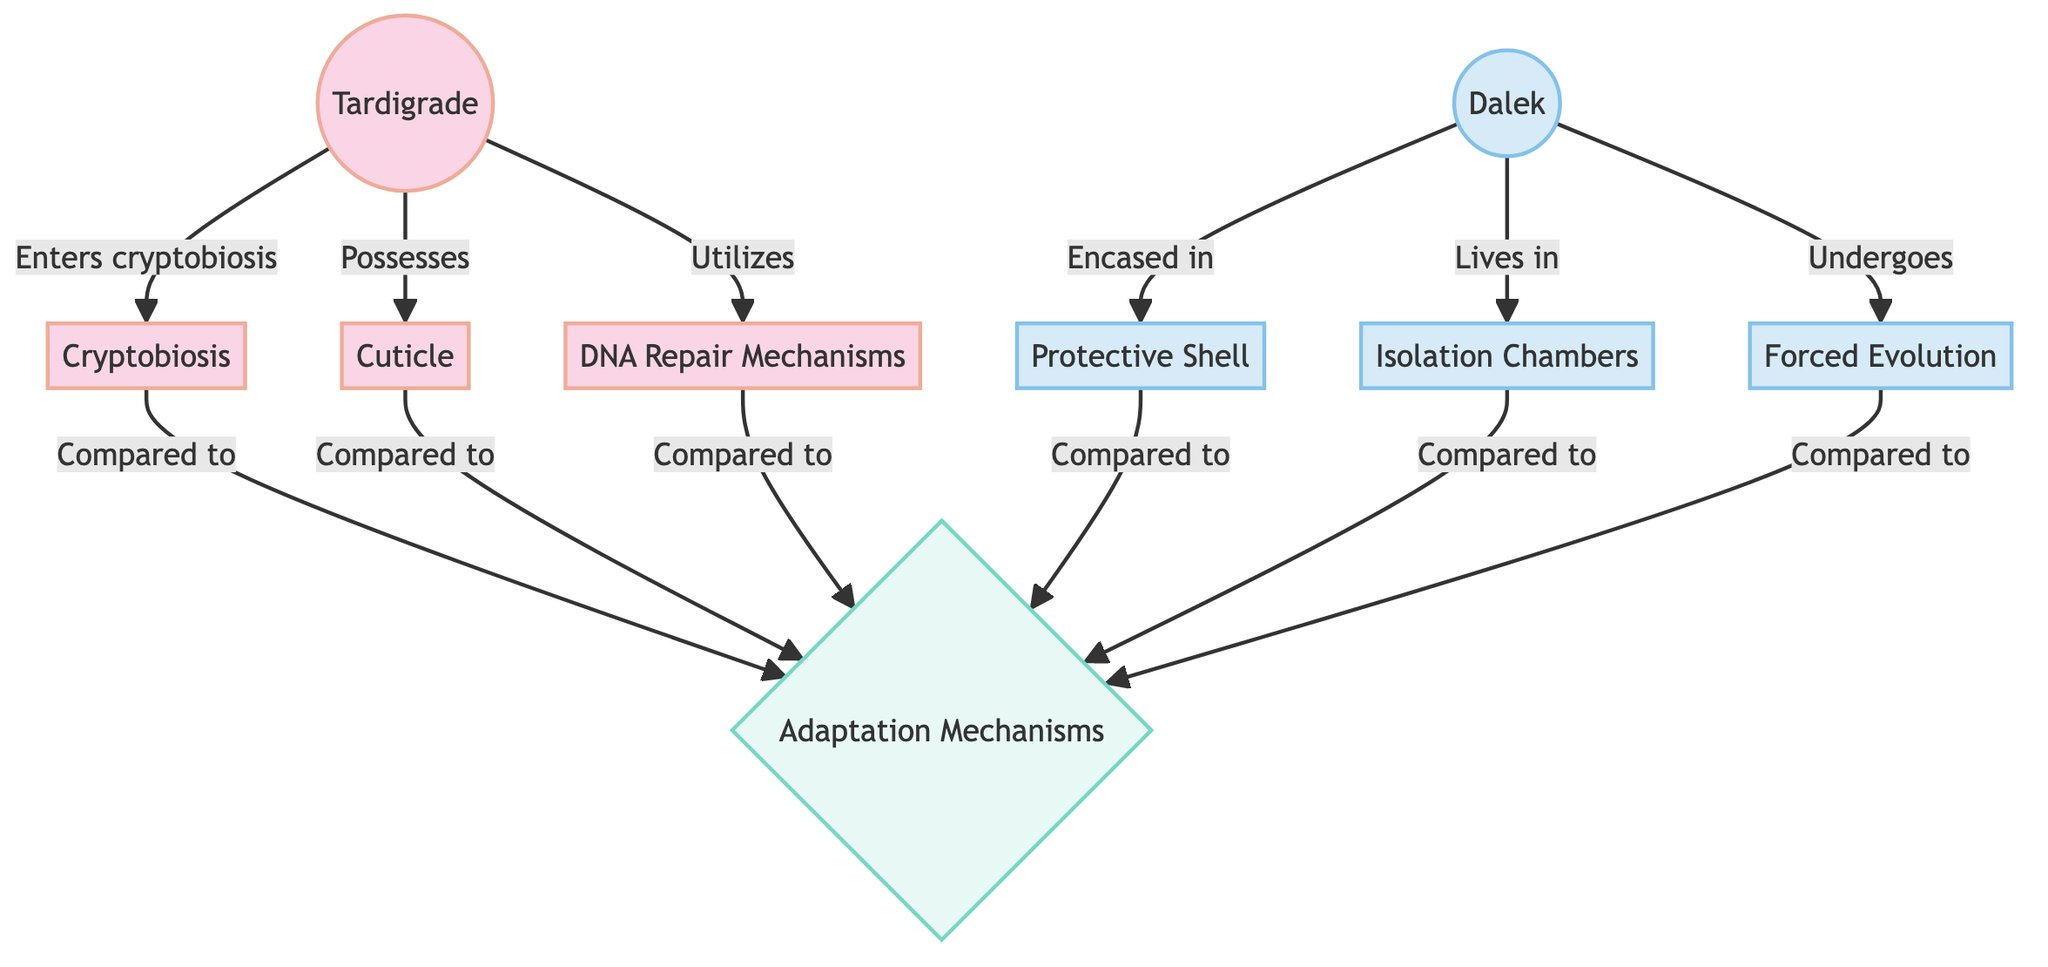What are the three mechanisms of adaptation for tardigrades? The diagram shows that tardigrades utilize three specific adaptation mechanisms: cryptobiosis, a cuticle, and DNA repair mechanisms, all directly linked to the tardigrade node.
Answer: cryptobiosis, cuticle, DNA repair mechanisms How many adaptation mechanisms are shown in total? The diagram displays a total of six adaptation mechanisms, three for tardigrades and three for Daleks, connected to the comparison node.
Answer: six To which adaptation mechanism does the term "Forced Evolution" relate? The term "Forced Evolution" is associated with the Dalek node, indicating one of the unique biological adaptations that Daleks employ for survival.
Answer: Forced Evolution What is the relationship between cryptobiosis and comparison? The diagram shows that cryptobiosis is directly linked to the comparison node, meaning it is one of the elements compared between the tardigrades and Daleks regarding adaptation mechanisms.
Answer: Compared to Which protective feature is directly associated with Daleks? The diagram identifies "Protective Shell" as the protective feature that is directly associated with Daleks, connected to the Dalek node.
Answer: Protective Shell How many features or mechanisms are unique to tardigrades? There are three features or mechanisms unique to tardigrades listed in the diagram indicating their specific adaptations for survival.
Answer: three What does the term "Isolation Chambers" refer to, in the context of the diagram? "Isolation Chambers" refers to one of the adaptation mechanisms employed by Daleks that informs how they survive in their extreme environments, as indicated in the flow from the Dalek node.
Answer: Isolation Chambers Which adaptation mechanism allows tardigrades to enter a dormant state? The adaptation mechanism that enables tardigrades to enter a dormant state is termed "cryptobiosis," which is clearly marked in the flowchart.
Answer: cryptobiosis 